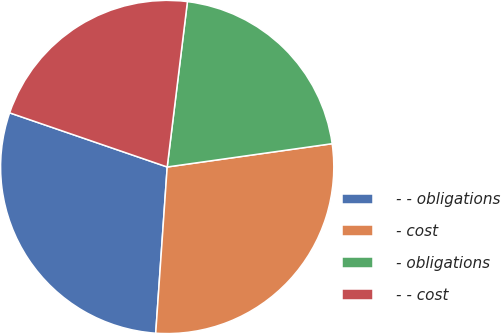<chart> <loc_0><loc_0><loc_500><loc_500><pie_chart><fcel>- - obligations<fcel>- cost<fcel>- obligations<fcel>- - cost<nl><fcel>29.17%<fcel>28.33%<fcel>20.83%<fcel>21.67%<nl></chart> 